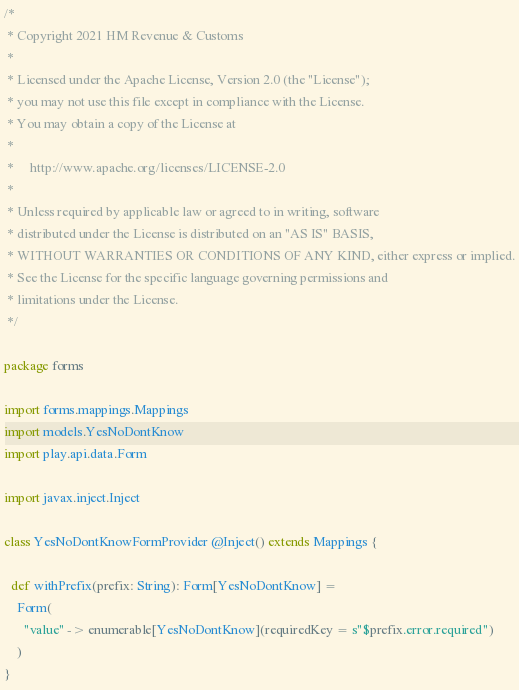Convert code to text. <code><loc_0><loc_0><loc_500><loc_500><_Scala_>/*
 * Copyright 2021 HM Revenue & Customs
 *
 * Licensed under the Apache License, Version 2.0 (the "License");
 * you may not use this file except in compliance with the License.
 * You may obtain a copy of the License at
 *
 *     http://www.apache.org/licenses/LICENSE-2.0
 *
 * Unless required by applicable law or agreed to in writing, software
 * distributed under the License is distributed on an "AS IS" BASIS,
 * WITHOUT WARRANTIES OR CONDITIONS OF ANY KIND, either express or implied.
 * See the License for the specific language governing permissions and
 * limitations under the License.
 */

package forms

import forms.mappings.Mappings
import models.YesNoDontKnow
import play.api.data.Form

import javax.inject.Inject

class YesNoDontKnowFormProvider @Inject() extends Mappings {

  def withPrefix(prefix: String): Form[YesNoDontKnow] =
    Form(
      "value" -> enumerable[YesNoDontKnow](requiredKey = s"$prefix.error.required")
    )
}
</code> 